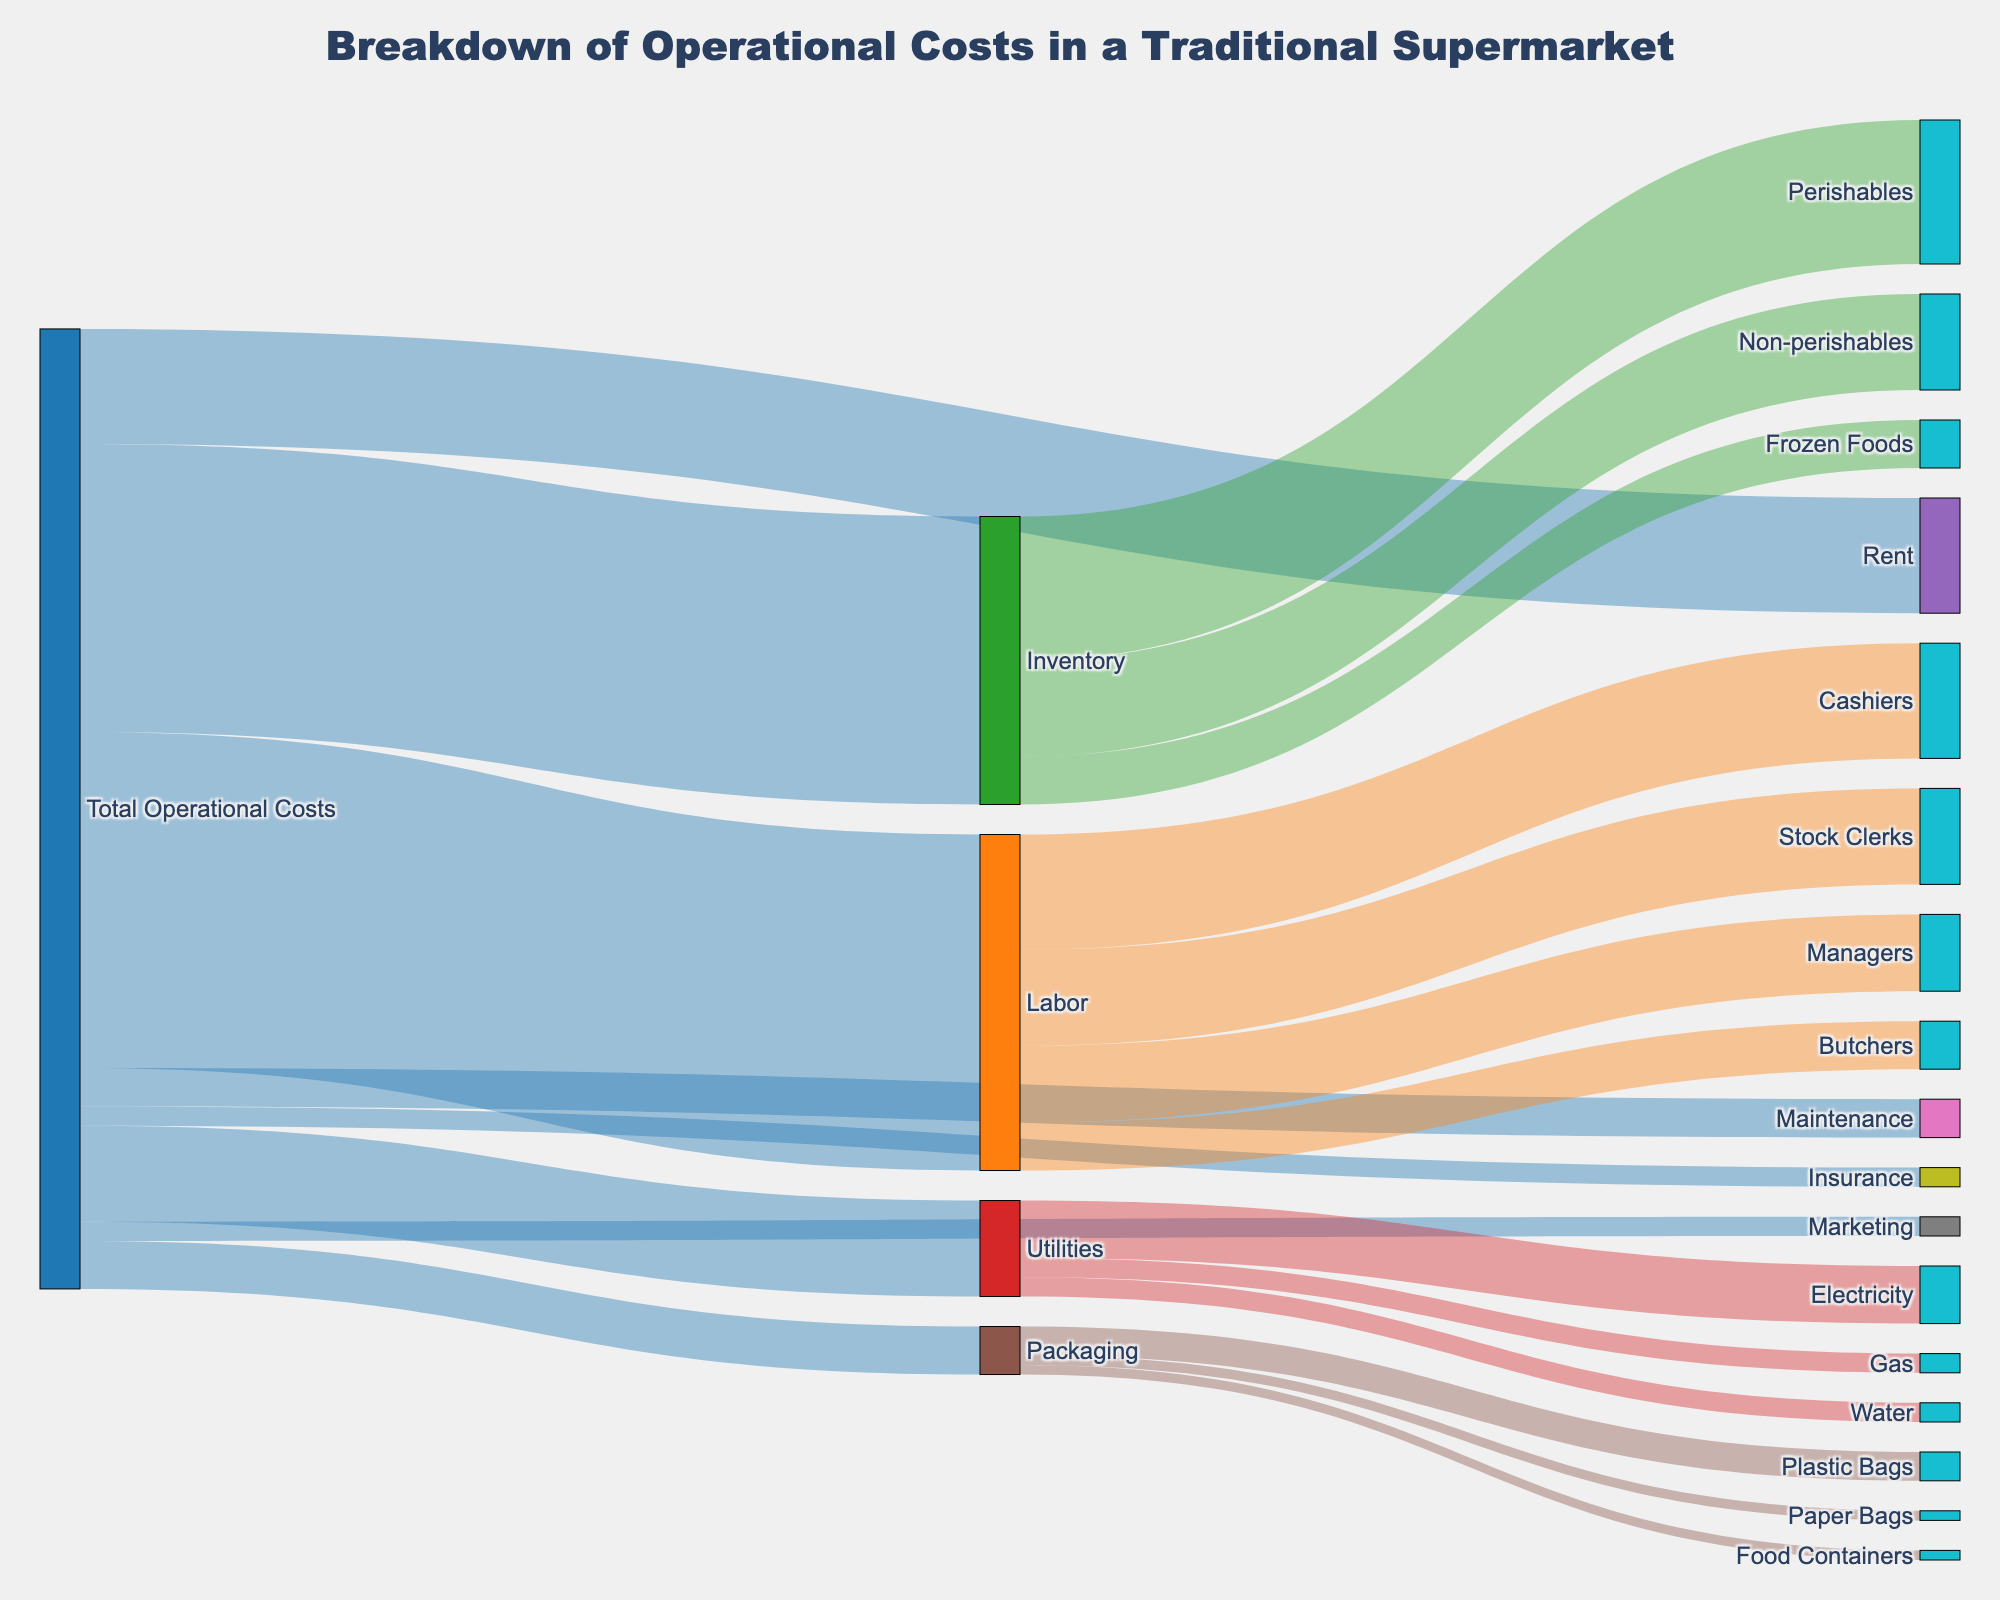what's the title of the diagram? The title of the diagram is usually found at the top of the figure. It provides a quick reference to understand what the diagram is about.
Answer: Breakdown of Operational Costs in a Traditional Supermarket How much of the total operational costs is accounted for by labor? To find this, look at the link from "Total Operational Costs" to "Labor". The value is labeled as 35 in the figure.
Answer: 35 Which category has the smallest share of the total operational costs, and what is its value? By examining the links from "Total Operational Costs", identify the category with the smallest value. The figure shows "Marketing" and "Insurance" each with a value of 2.
Answer: Marketing and Insurance, 2 each What percentage of the labor costs are attributed to cashiers? First, identify the total value for labor costs (35). Then, find the value attributed to cashiers (12). The percentage is calculated as (12 / 35) * 100.
Answer: Approximately 34.3% Compare the total costs of inventory with utilities. Which one is greater and by how much? Sum the values from the "Inventory" links (15 + 10 + 5 = 30) and compare it to the sum of the "Utilities" values (6 + 2 + 2 = 10). Inventory (30) is greater than utilities (10) by 20.
Answer: Inventory is greater by 20 What's the total value of packaging costs and how is it distributed among its subcategories? Add up the values linked from "Packaging" (3 for Plastic Bags, 1 for Paper Bags, and 1 for Food Containers). The total is 3 + 1 + 1 = 5.
Answer: Total is 5, distributed as Plastic Bags: 3, Paper Bags: 1, Food Containers: 1 How much does the cost of rent compare to the cost of marketing and insurance combined? Rent is valued at 12. Marketing and Insurance combined is 2 + 2 = 4. Comparing these, rent (12) is greater by 8.
Answer: Rent is greater by 8 Which labor subcategory has the least cost, and what is the value? Examine the subcategories linked to "Labor". "Butchers" have the least value, which is 5.
Answer: Butchers, 5 Considering utilities, which subcategory costs the most and what value does it have? Within the branches of "Utilities", "Electricity" has the highest value of 6.
Answer: Electricity, 6 